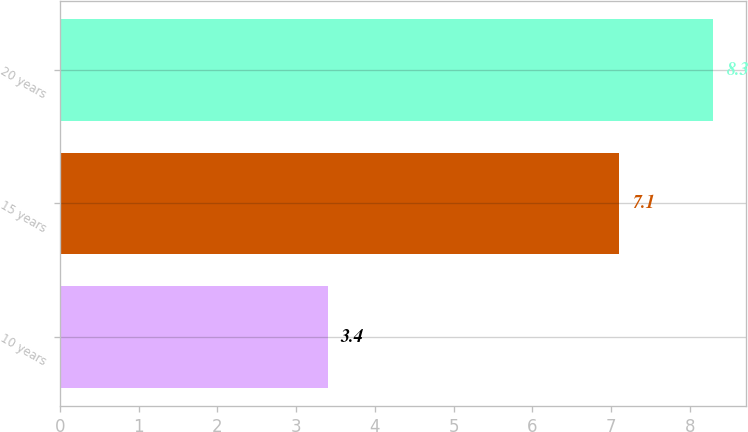Convert chart. <chart><loc_0><loc_0><loc_500><loc_500><bar_chart><fcel>10 years<fcel>15 years<fcel>20 years<nl><fcel>3.4<fcel>7.1<fcel>8.3<nl></chart> 